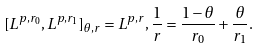<formula> <loc_0><loc_0><loc_500><loc_500>[ L ^ { p , r _ { 0 } } , L ^ { p , r _ { 1 } } ] _ { \theta , r } = L ^ { p , r } , \frac { 1 } { r } = \frac { 1 - \theta } { r _ { 0 } } + \frac { \theta } { r _ { 1 } } .</formula> 